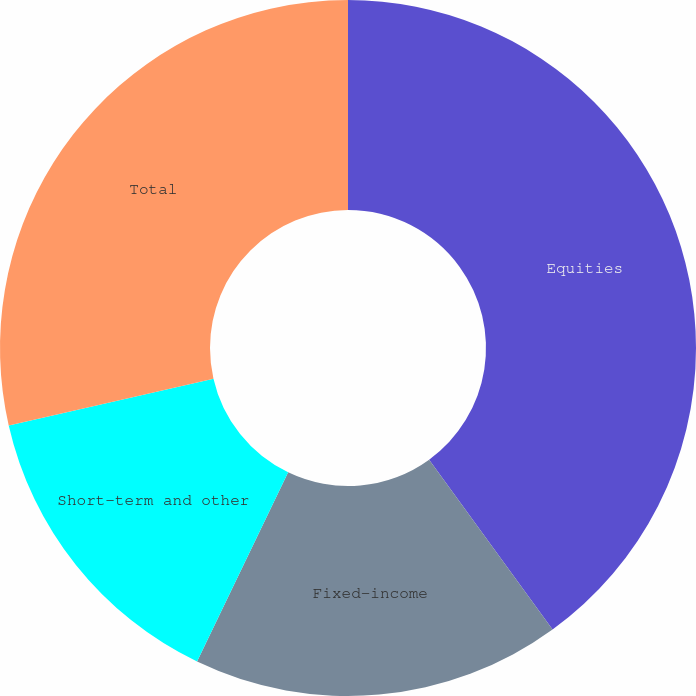<chart> <loc_0><loc_0><loc_500><loc_500><pie_chart><fcel>Equities<fcel>Fixed-income<fcel>Short-term and other<fcel>Total<nl><fcel>40.0%<fcel>17.14%<fcel>14.29%<fcel>28.57%<nl></chart> 